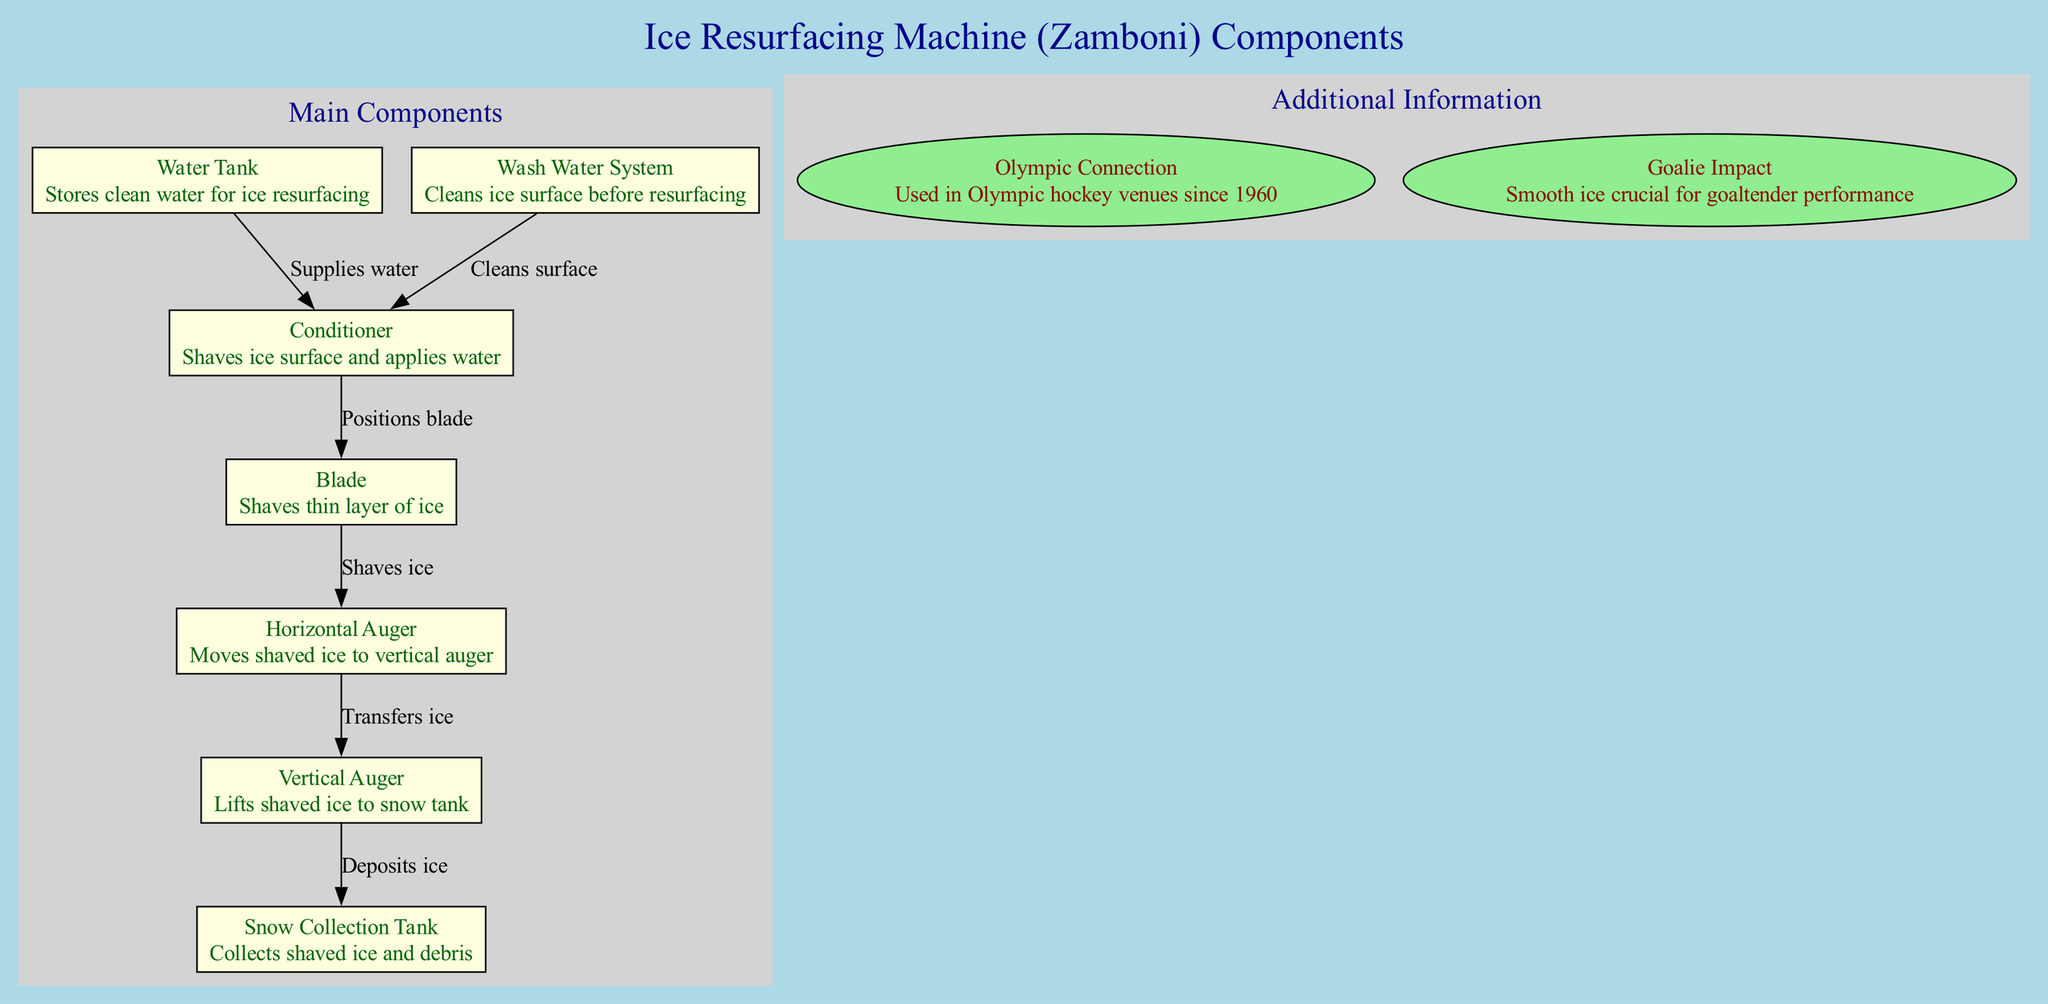What are the main components of the machine? The diagram specifies the main components of the Zamboni, which are: Water Tank, Snow Collection Tank, Conditioner, Horizontal Auger, Vertical Auger, Wash Water System, and Blade. By reviewing the labeled nodes, I can confirm these seven parts.
Answer: Water Tank, Snow Collection Tank, Conditioner, Horizontal Auger, Vertical Auger, Wash Water System, Blade How many edges connect the main components? To determine the number of edges, I look at the connections illustrated between nodes in the main components cluster. There are six distinct edges linking the components based on the diagram's layout.
Answer: 6 What is the function of the Blade? The Blade's function is clearly labeled in the diagram, indicating that it shaves a thin layer of ice. This specific description is included with the node for the Blade.
Answer: Shaves thin layer of ice Which component collects shaved ice and debris? By examining the diagram, the Snow Collection Tank is labeled with the function of collecting shaved ice and debris, allowing me to directly identify it as the answer.
Answer: Snow Collection Tank What supplies water to the Conditioner? According to the diagram's flow, the Water Tank supplies water to the Conditioner. This connection is specifically noted in the directed edge from Water Tank to Conditioner.
Answer: Water Tank How does the Wash Water System affect the Conditioner? The diagram indicates that the Wash Water System cleans the ice surface before resurfacing it, specifically supplying to the Conditioner for this purpose, which establishes a direct relationship impacting its performance.
Answer: Cleans surface What is the role of the Vertical Auger in the process? The labeled function for the Vertical Auger in the diagram states that it lifts shaved ice to the snow tank, highlighting its specific purpose in handling shaved ice.
Answer: Lifts shaved ice to snow tank How long has this machine been used in Olympic hockey venues? The additional information section of the diagram explicitly states that the Zamboni has been used in Olympic hockey venues since 1960, giving a clear historical reference.
Answer: Since 1960 Why is smooth ice crucial for goaltender performance? The diagram explains that smooth ice is critical for goaltender performance, indicating its importance in maintaining the quality of the playing surface for optimal play.
Answer: Smooth ice crucial for goaltender performance 